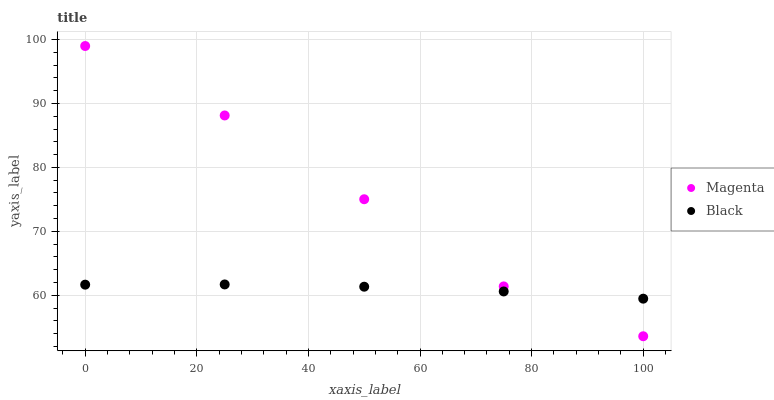Does Black have the minimum area under the curve?
Answer yes or no. Yes. Does Magenta have the maximum area under the curve?
Answer yes or no. Yes. Does Black have the maximum area under the curve?
Answer yes or no. No. Is Black the smoothest?
Answer yes or no. Yes. Is Magenta the roughest?
Answer yes or no. Yes. Is Black the roughest?
Answer yes or no. No. Does Magenta have the lowest value?
Answer yes or no. Yes. Does Black have the lowest value?
Answer yes or no. No. Does Magenta have the highest value?
Answer yes or no. Yes. Does Black have the highest value?
Answer yes or no. No. Does Magenta intersect Black?
Answer yes or no. Yes. Is Magenta less than Black?
Answer yes or no. No. Is Magenta greater than Black?
Answer yes or no. No. 